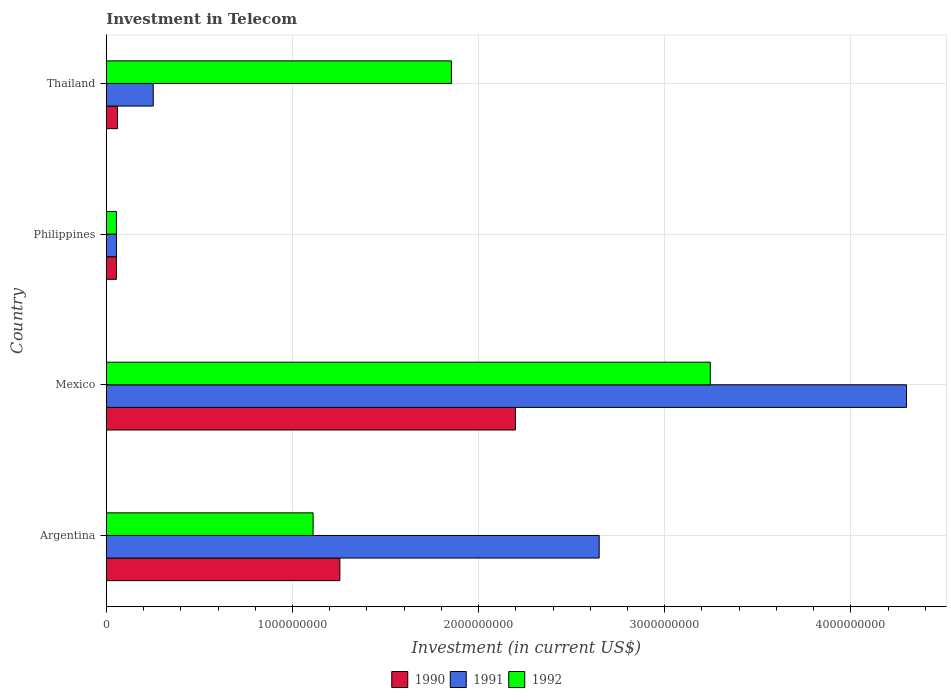Are the number of bars on each tick of the Y-axis equal?
Offer a terse response. Yes. How many bars are there on the 4th tick from the top?
Offer a very short reply. 3. How many bars are there on the 2nd tick from the bottom?
Your answer should be compact. 3. What is the label of the 1st group of bars from the top?
Offer a terse response. Thailand. In how many cases, is the number of bars for a given country not equal to the number of legend labels?
Offer a terse response. 0. What is the amount invested in telecom in 1990 in Philippines?
Keep it short and to the point. 5.42e+07. Across all countries, what is the maximum amount invested in telecom in 1991?
Your response must be concise. 4.30e+09. Across all countries, what is the minimum amount invested in telecom in 1992?
Provide a succinct answer. 5.42e+07. In which country was the amount invested in telecom in 1992 maximum?
Make the answer very short. Mexico. What is the total amount invested in telecom in 1991 in the graph?
Your response must be concise. 7.25e+09. What is the difference between the amount invested in telecom in 1992 in Argentina and that in Thailand?
Your response must be concise. -7.43e+08. What is the difference between the amount invested in telecom in 1991 in Argentina and the amount invested in telecom in 1992 in Thailand?
Give a very brief answer. 7.94e+08. What is the average amount invested in telecom in 1991 per country?
Ensure brevity in your answer.  1.81e+09. What is the difference between the amount invested in telecom in 1990 and amount invested in telecom in 1991 in Mexico?
Your answer should be very brief. -2.10e+09. In how many countries, is the amount invested in telecom in 1990 greater than 3800000000 US$?
Offer a very short reply. 0. What is the ratio of the amount invested in telecom in 1990 in Mexico to that in Philippines?
Keep it short and to the point. 40.55. What is the difference between the highest and the second highest amount invested in telecom in 1991?
Offer a terse response. 1.65e+09. What is the difference between the highest and the lowest amount invested in telecom in 1991?
Offer a terse response. 4.24e+09. Is the sum of the amount invested in telecom in 1990 in Philippines and Thailand greater than the maximum amount invested in telecom in 1991 across all countries?
Offer a very short reply. No. What does the 1st bar from the bottom in Argentina represents?
Your answer should be compact. 1990. Is it the case that in every country, the sum of the amount invested in telecom in 1992 and amount invested in telecom in 1990 is greater than the amount invested in telecom in 1991?
Offer a terse response. No. How many bars are there?
Your answer should be compact. 12. How many legend labels are there?
Keep it short and to the point. 3. How are the legend labels stacked?
Ensure brevity in your answer.  Horizontal. What is the title of the graph?
Make the answer very short. Investment in Telecom. Does "1998" appear as one of the legend labels in the graph?
Your response must be concise. No. What is the label or title of the X-axis?
Offer a very short reply. Investment (in current US$). What is the Investment (in current US$) of 1990 in Argentina?
Provide a short and direct response. 1.25e+09. What is the Investment (in current US$) in 1991 in Argentina?
Make the answer very short. 2.65e+09. What is the Investment (in current US$) in 1992 in Argentina?
Keep it short and to the point. 1.11e+09. What is the Investment (in current US$) of 1990 in Mexico?
Keep it short and to the point. 2.20e+09. What is the Investment (in current US$) of 1991 in Mexico?
Provide a short and direct response. 4.30e+09. What is the Investment (in current US$) of 1992 in Mexico?
Provide a succinct answer. 3.24e+09. What is the Investment (in current US$) in 1990 in Philippines?
Offer a very short reply. 5.42e+07. What is the Investment (in current US$) in 1991 in Philippines?
Make the answer very short. 5.42e+07. What is the Investment (in current US$) in 1992 in Philippines?
Provide a succinct answer. 5.42e+07. What is the Investment (in current US$) of 1990 in Thailand?
Provide a short and direct response. 6.00e+07. What is the Investment (in current US$) in 1991 in Thailand?
Your response must be concise. 2.52e+08. What is the Investment (in current US$) of 1992 in Thailand?
Keep it short and to the point. 1.85e+09. Across all countries, what is the maximum Investment (in current US$) of 1990?
Make the answer very short. 2.20e+09. Across all countries, what is the maximum Investment (in current US$) in 1991?
Keep it short and to the point. 4.30e+09. Across all countries, what is the maximum Investment (in current US$) of 1992?
Your answer should be very brief. 3.24e+09. Across all countries, what is the minimum Investment (in current US$) in 1990?
Your response must be concise. 5.42e+07. Across all countries, what is the minimum Investment (in current US$) in 1991?
Offer a very short reply. 5.42e+07. Across all countries, what is the minimum Investment (in current US$) of 1992?
Offer a very short reply. 5.42e+07. What is the total Investment (in current US$) of 1990 in the graph?
Provide a succinct answer. 3.57e+09. What is the total Investment (in current US$) of 1991 in the graph?
Give a very brief answer. 7.25e+09. What is the total Investment (in current US$) in 1992 in the graph?
Your answer should be compact. 6.26e+09. What is the difference between the Investment (in current US$) of 1990 in Argentina and that in Mexico?
Provide a succinct answer. -9.43e+08. What is the difference between the Investment (in current US$) of 1991 in Argentina and that in Mexico?
Provide a succinct answer. -1.65e+09. What is the difference between the Investment (in current US$) in 1992 in Argentina and that in Mexico?
Keep it short and to the point. -2.13e+09. What is the difference between the Investment (in current US$) of 1990 in Argentina and that in Philippines?
Give a very brief answer. 1.20e+09. What is the difference between the Investment (in current US$) of 1991 in Argentina and that in Philippines?
Offer a terse response. 2.59e+09. What is the difference between the Investment (in current US$) of 1992 in Argentina and that in Philippines?
Your answer should be very brief. 1.06e+09. What is the difference between the Investment (in current US$) in 1990 in Argentina and that in Thailand?
Give a very brief answer. 1.19e+09. What is the difference between the Investment (in current US$) in 1991 in Argentina and that in Thailand?
Offer a terse response. 2.40e+09. What is the difference between the Investment (in current US$) of 1992 in Argentina and that in Thailand?
Ensure brevity in your answer.  -7.43e+08. What is the difference between the Investment (in current US$) of 1990 in Mexico and that in Philippines?
Provide a short and direct response. 2.14e+09. What is the difference between the Investment (in current US$) of 1991 in Mexico and that in Philippines?
Your answer should be very brief. 4.24e+09. What is the difference between the Investment (in current US$) of 1992 in Mexico and that in Philippines?
Provide a succinct answer. 3.19e+09. What is the difference between the Investment (in current US$) of 1990 in Mexico and that in Thailand?
Provide a short and direct response. 2.14e+09. What is the difference between the Investment (in current US$) in 1991 in Mexico and that in Thailand?
Provide a short and direct response. 4.05e+09. What is the difference between the Investment (in current US$) in 1992 in Mexico and that in Thailand?
Provide a short and direct response. 1.39e+09. What is the difference between the Investment (in current US$) in 1990 in Philippines and that in Thailand?
Offer a terse response. -5.80e+06. What is the difference between the Investment (in current US$) of 1991 in Philippines and that in Thailand?
Your response must be concise. -1.98e+08. What is the difference between the Investment (in current US$) in 1992 in Philippines and that in Thailand?
Your response must be concise. -1.80e+09. What is the difference between the Investment (in current US$) in 1990 in Argentina and the Investment (in current US$) in 1991 in Mexico?
Offer a very short reply. -3.04e+09. What is the difference between the Investment (in current US$) in 1990 in Argentina and the Investment (in current US$) in 1992 in Mexico?
Make the answer very short. -1.99e+09. What is the difference between the Investment (in current US$) in 1991 in Argentina and the Investment (in current US$) in 1992 in Mexico?
Make the answer very short. -5.97e+08. What is the difference between the Investment (in current US$) of 1990 in Argentina and the Investment (in current US$) of 1991 in Philippines?
Make the answer very short. 1.20e+09. What is the difference between the Investment (in current US$) of 1990 in Argentina and the Investment (in current US$) of 1992 in Philippines?
Offer a very short reply. 1.20e+09. What is the difference between the Investment (in current US$) in 1991 in Argentina and the Investment (in current US$) in 1992 in Philippines?
Make the answer very short. 2.59e+09. What is the difference between the Investment (in current US$) in 1990 in Argentina and the Investment (in current US$) in 1991 in Thailand?
Offer a terse response. 1.00e+09. What is the difference between the Investment (in current US$) of 1990 in Argentina and the Investment (in current US$) of 1992 in Thailand?
Your answer should be very brief. -5.99e+08. What is the difference between the Investment (in current US$) of 1991 in Argentina and the Investment (in current US$) of 1992 in Thailand?
Offer a very short reply. 7.94e+08. What is the difference between the Investment (in current US$) of 1990 in Mexico and the Investment (in current US$) of 1991 in Philippines?
Your response must be concise. 2.14e+09. What is the difference between the Investment (in current US$) in 1990 in Mexico and the Investment (in current US$) in 1992 in Philippines?
Your response must be concise. 2.14e+09. What is the difference between the Investment (in current US$) of 1991 in Mexico and the Investment (in current US$) of 1992 in Philippines?
Make the answer very short. 4.24e+09. What is the difference between the Investment (in current US$) of 1990 in Mexico and the Investment (in current US$) of 1991 in Thailand?
Offer a very short reply. 1.95e+09. What is the difference between the Investment (in current US$) of 1990 in Mexico and the Investment (in current US$) of 1992 in Thailand?
Provide a succinct answer. 3.44e+08. What is the difference between the Investment (in current US$) of 1991 in Mexico and the Investment (in current US$) of 1992 in Thailand?
Make the answer very short. 2.44e+09. What is the difference between the Investment (in current US$) of 1990 in Philippines and the Investment (in current US$) of 1991 in Thailand?
Offer a very short reply. -1.98e+08. What is the difference between the Investment (in current US$) of 1990 in Philippines and the Investment (in current US$) of 1992 in Thailand?
Your answer should be very brief. -1.80e+09. What is the difference between the Investment (in current US$) of 1991 in Philippines and the Investment (in current US$) of 1992 in Thailand?
Offer a very short reply. -1.80e+09. What is the average Investment (in current US$) of 1990 per country?
Ensure brevity in your answer.  8.92e+08. What is the average Investment (in current US$) of 1991 per country?
Keep it short and to the point. 1.81e+09. What is the average Investment (in current US$) in 1992 per country?
Offer a very short reply. 1.57e+09. What is the difference between the Investment (in current US$) of 1990 and Investment (in current US$) of 1991 in Argentina?
Offer a very short reply. -1.39e+09. What is the difference between the Investment (in current US$) of 1990 and Investment (in current US$) of 1992 in Argentina?
Provide a short and direct response. 1.44e+08. What is the difference between the Investment (in current US$) of 1991 and Investment (in current US$) of 1992 in Argentina?
Provide a short and direct response. 1.54e+09. What is the difference between the Investment (in current US$) in 1990 and Investment (in current US$) in 1991 in Mexico?
Offer a terse response. -2.10e+09. What is the difference between the Investment (in current US$) of 1990 and Investment (in current US$) of 1992 in Mexico?
Your answer should be compact. -1.05e+09. What is the difference between the Investment (in current US$) of 1991 and Investment (in current US$) of 1992 in Mexico?
Give a very brief answer. 1.05e+09. What is the difference between the Investment (in current US$) in 1990 and Investment (in current US$) in 1991 in Philippines?
Provide a succinct answer. 0. What is the difference between the Investment (in current US$) in 1991 and Investment (in current US$) in 1992 in Philippines?
Your answer should be compact. 0. What is the difference between the Investment (in current US$) in 1990 and Investment (in current US$) in 1991 in Thailand?
Ensure brevity in your answer.  -1.92e+08. What is the difference between the Investment (in current US$) in 1990 and Investment (in current US$) in 1992 in Thailand?
Provide a short and direct response. -1.79e+09. What is the difference between the Investment (in current US$) in 1991 and Investment (in current US$) in 1992 in Thailand?
Offer a terse response. -1.60e+09. What is the ratio of the Investment (in current US$) of 1990 in Argentina to that in Mexico?
Provide a succinct answer. 0.57. What is the ratio of the Investment (in current US$) of 1991 in Argentina to that in Mexico?
Provide a short and direct response. 0.62. What is the ratio of the Investment (in current US$) of 1992 in Argentina to that in Mexico?
Ensure brevity in your answer.  0.34. What is the ratio of the Investment (in current US$) of 1990 in Argentina to that in Philippines?
Offer a terse response. 23.15. What is the ratio of the Investment (in current US$) in 1991 in Argentina to that in Philippines?
Offer a terse response. 48.86. What is the ratio of the Investment (in current US$) in 1992 in Argentina to that in Philippines?
Offer a terse response. 20.5. What is the ratio of the Investment (in current US$) in 1990 in Argentina to that in Thailand?
Offer a terse response. 20.91. What is the ratio of the Investment (in current US$) of 1991 in Argentina to that in Thailand?
Your answer should be compact. 10.51. What is the ratio of the Investment (in current US$) of 1992 in Argentina to that in Thailand?
Your response must be concise. 0.6. What is the ratio of the Investment (in current US$) in 1990 in Mexico to that in Philippines?
Provide a short and direct response. 40.55. What is the ratio of the Investment (in current US$) of 1991 in Mexico to that in Philippines?
Provide a short and direct response. 79.32. What is the ratio of the Investment (in current US$) of 1992 in Mexico to that in Philippines?
Your answer should be compact. 59.87. What is the ratio of the Investment (in current US$) in 1990 in Mexico to that in Thailand?
Make the answer very short. 36.63. What is the ratio of the Investment (in current US$) in 1991 in Mexico to that in Thailand?
Give a very brief answer. 17.06. What is the ratio of the Investment (in current US$) in 1992 in Mexico to that in Thailand?
Offer a terse response. 1.75. What is the ratio of the Investment (in current US$) in 1990 in Philippines to that in Thailand?
Give a very brief answer. 0.9. What is the ratio of the Investment (in current US$) in 1991 in Philippines to that in Thailand?
Ensure brevity in your answer.  0.22. What is the ratio of the Investment (in current US$) in 1992 in Philippines to that in Thailand?
Your answer should be compact. 0.03. What is the difference between the highest and the second highest Investment (in current US$) in 1990?
Offer a terse response. 9.43e+08. What is the difference between the highest and the second highest Investment (in current US$) in 1991?
Provide a succinct answer. 1.65e+09. What is the difference between the highest and the second highest Investment (in current US$) of 1992?
Offer a terse response. 1.39e+09. What is the difference between the highest and the lowest Investment (in current US$) of 1990?
Provide a short and direct response. 2.14e+09. What is the difference between the highest and the lowest Investment (in current US$) of 1991?
Make the answer very short. 4.24e+09. What is the difference between the highest and the lowest Investment (in current US$) in 1992?
Offer a very short reply. 3.19e+09. 